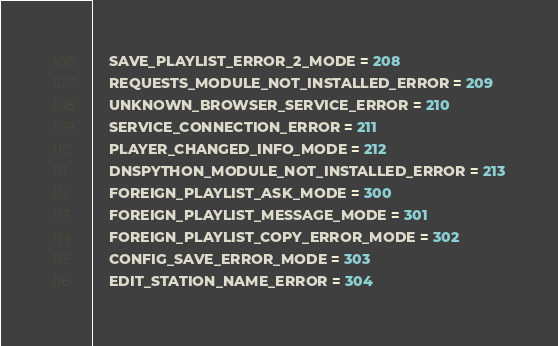<code> <loc_0><loc_0><loc_500><loc_500><_Python_>    SAVE_PLAYLIST_ERROR_2_MODE = 208
    REQUESTS_MODULE_NOT_INSTALLED_ERROR = 209
    UNKNOWN_BROWSER_SERVICE_ERROR = 210
    SERVICE_CONNECTION_ERROR = 211
    PLAYER_CHANGED_INFO_MODE = 212
    DNSPYTHON_MODULE_NOT_INSTALLED_ERROR = 213
    FOREIGN_PLAYLIST_ASK_MODE = 300
    FOREIGN_PLAYLIST_MESSAGE_MODE = 301
    FOREIGN_PLAYLIST_COPY_ERROR_MODE = 302
    CONFIG_SAVE_ERROR_MODE = 303
    EDIT_STATION_NAME_ERROR = 304</code> 